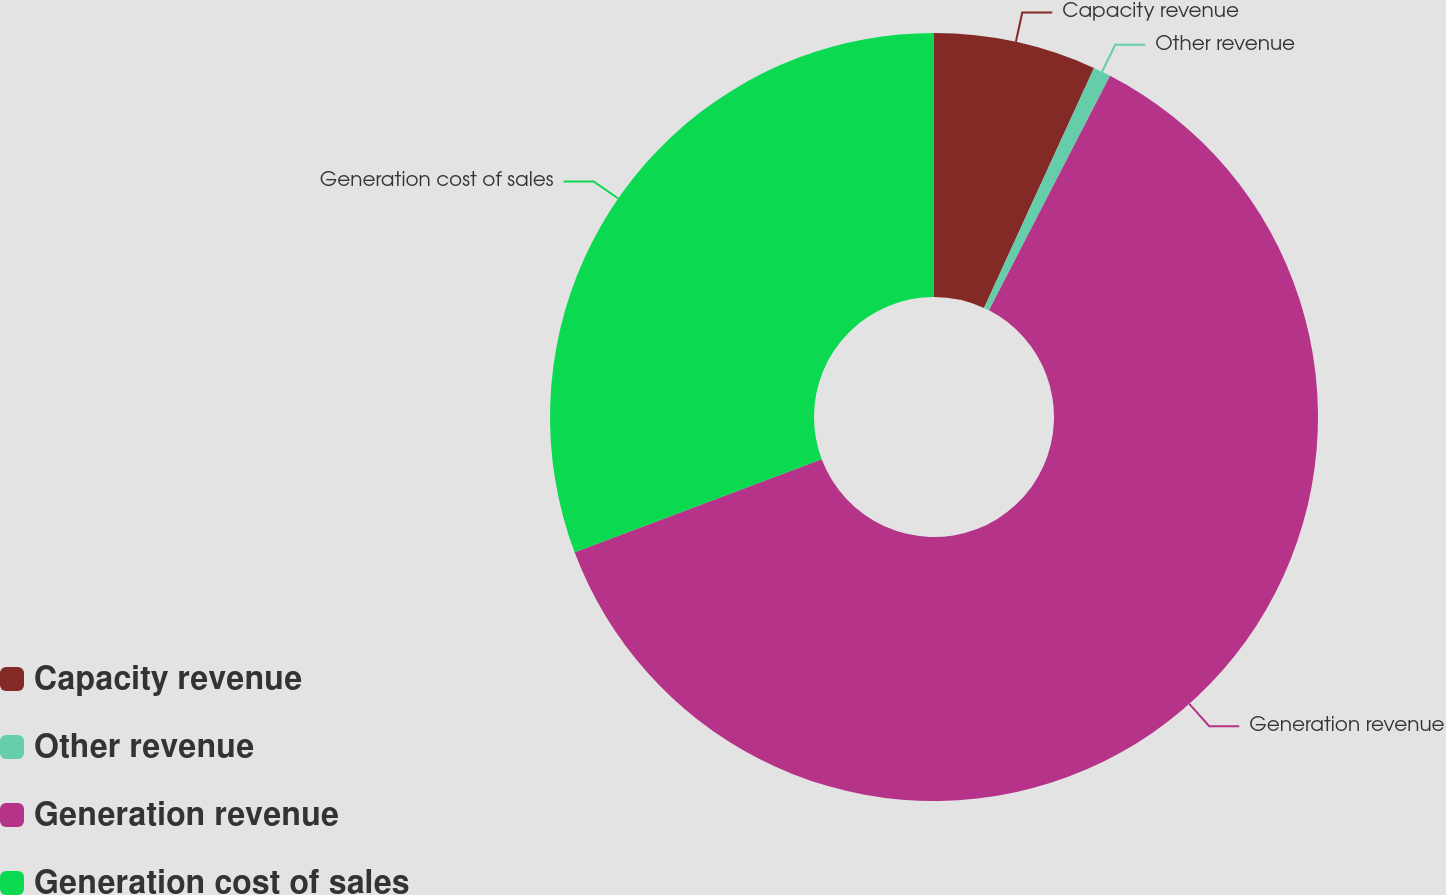<chart> <loc_0><loc_0><loc_500><loc_500><pie_chart><fcel>Capacity revenue<fcel>Other revenue<fcel>Generation revenue<fcel>Generation cost of sales<nl><fcel>6.84%<fcel>0.74%<fcel>61.69%<fcel>30.73%<nl></chart> 